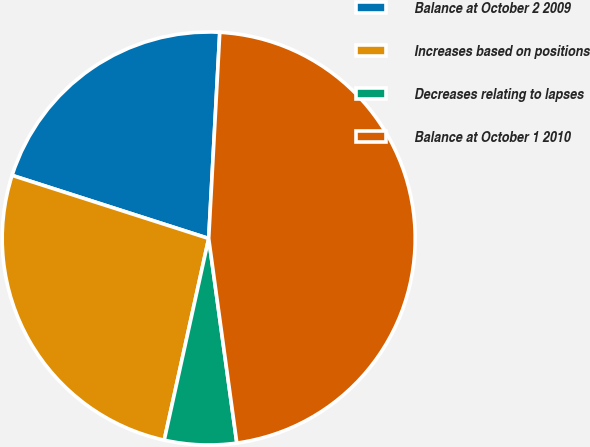<chart> <loc_0><loc_0><loc_500><loc_500><pie_chart><fcel>Balance at October 2 2009<fcel>Increases based on positions<fcel>Decreases relating to lapses<fcel>Balance at October 1 2010<nl><fcel>20.91%<fcel>26.49%<fcel>5.63%<fcel>46.97%<nl></chart> 